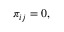<formula> <loc_0><loc_0><loc_500><loc_500>\begin{array} { r } { \pi _ { i j } = 0 , } \end{array}</formula> 